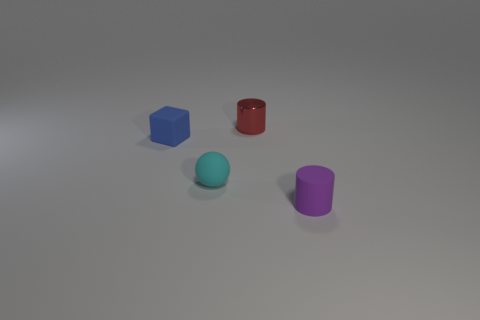Add 4 small purple cylinders. How many objects exist? 8 Subtract all cubes. How many objects are left? 3 Subtract 0 green cubes. How many objects are left? 4 Subtract all large gray cylinders. Subtract all tiny blocks. How many objects are left? 3 Add 3 tiny cylinders. How many tiny cylinders are left? 5 Add 1 big green metal spheres. How many big green metal spheres exist? 1 